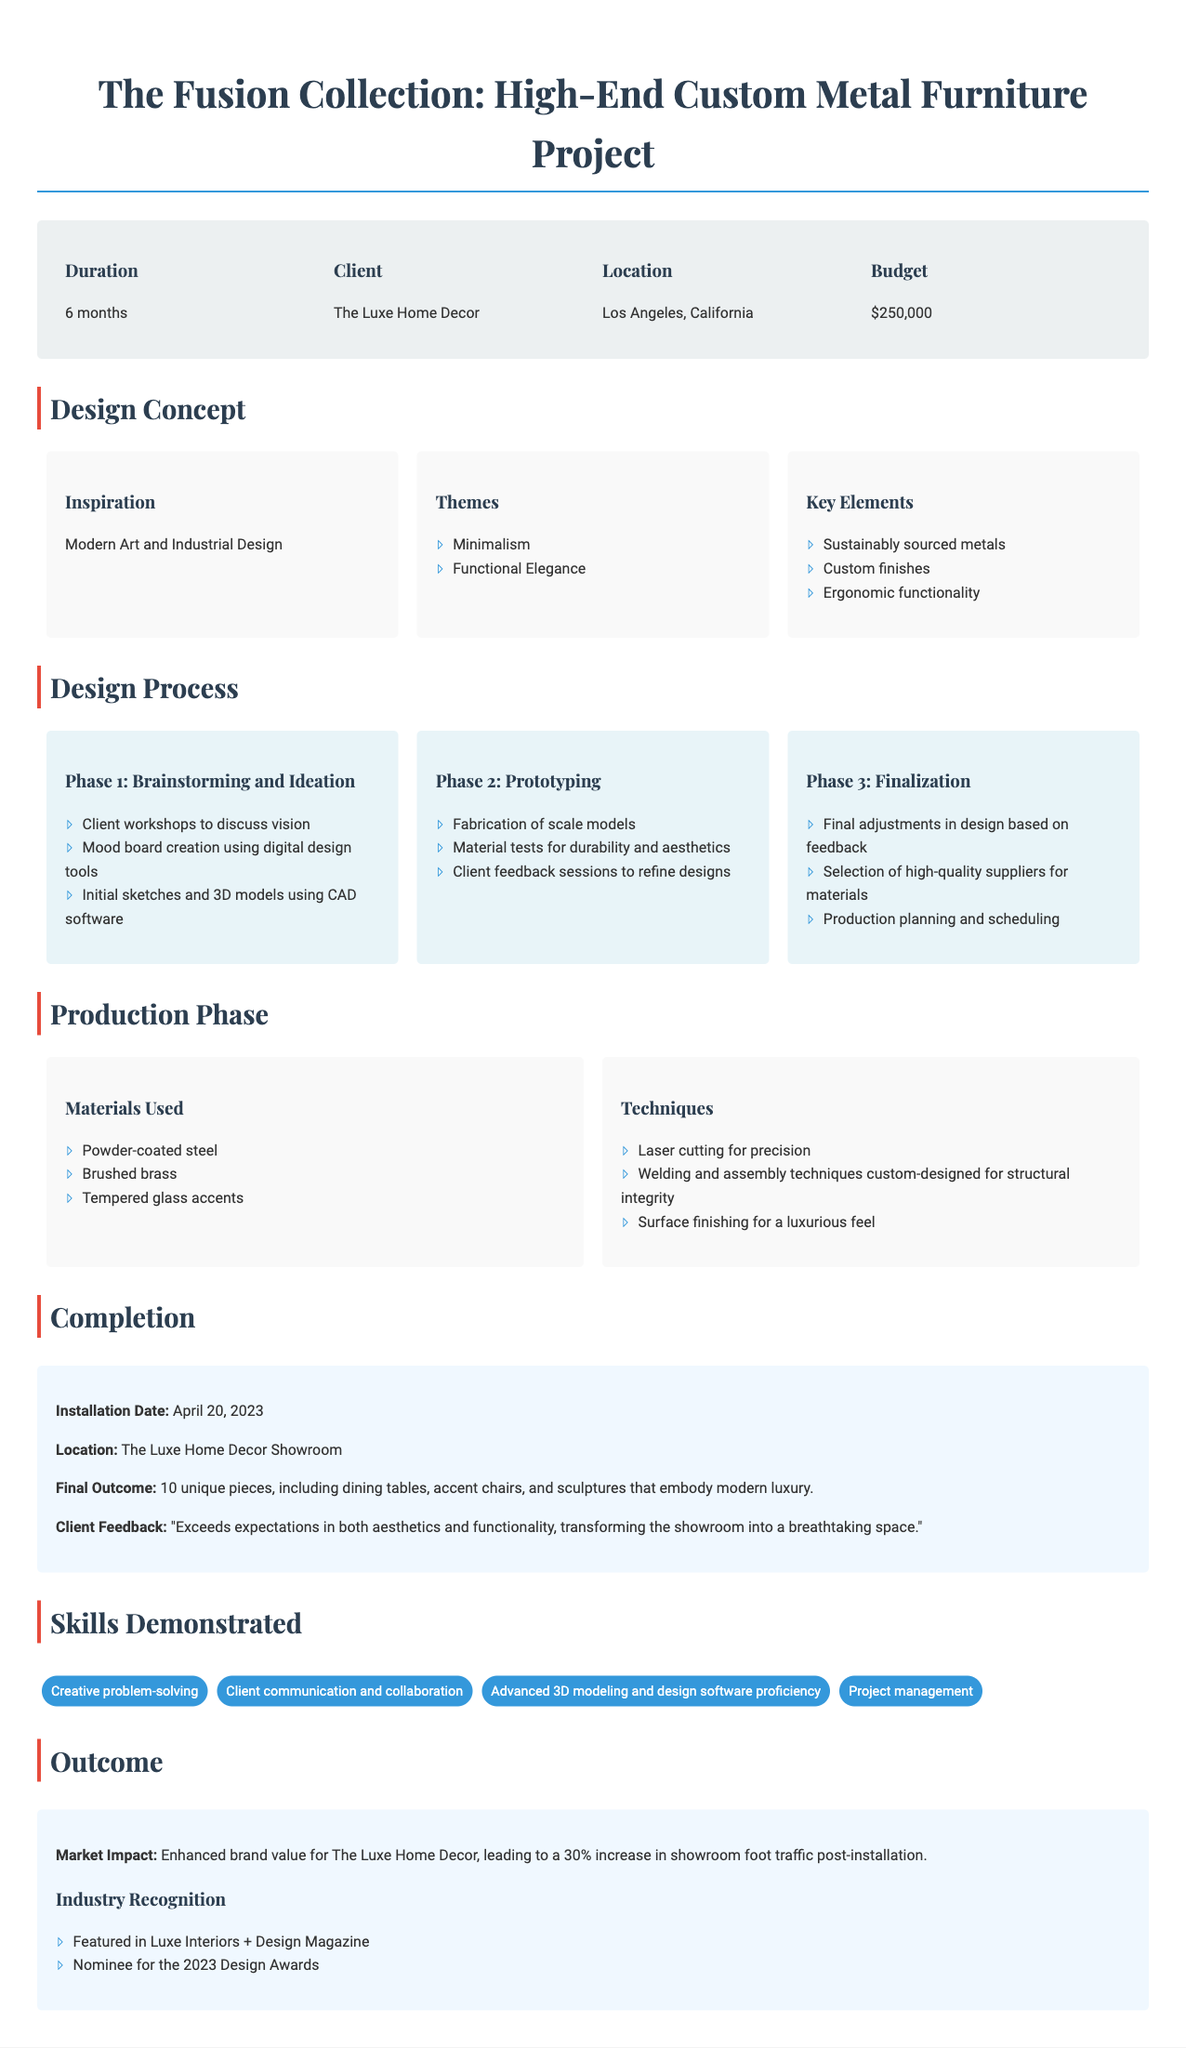What is the project duration? The project duration is stated in the document under the project overview section.
Answer: 6 months Who is the client for this project? The client's name is provided in the project overview section.
Answer: The Luxe Home Decor What is the budget allocated for the project? The budget amount is specified in the project overview section.
Answer: $250,000 Which materials were used in the production phase? The materials used are listed in the production phase section under "Materials Used."
Answer: Powder-coated steel, Brushed brass, Tempered glass accents What was the final outcome of the project? The final outcome can be found in the completion section, summarizing the number and types of pieces created.
Answer: 10 unique pieces, including dining tables, accent chairs, and sculptures What design themes were used? The themes are mentioned in the design concept section, highlighting the overall design direction.
Answer: Minimalism, Functional Elegance What brand value increase did The Luxe Home Decor experience post-installation? The increase in brand value is mentioned in the outcome section regarding market impact.
Answer: 30% When was the installation date? The installation date is provided in the completion section.
Answer: April 20, 2023 What industry recognition did the project receive? Industry recognition is listed under the outcome section, specifying notable mentions.
Answer: Featured in Luxe Interiors + Design Magazine What was the client’s feedback regarding the project? The client feedback is recorded in the completion section, summarizing their satisfaction.
Answer: Exceeds expectations in both aesthetics and functionality, transforming the showroom into a breathtaking space 